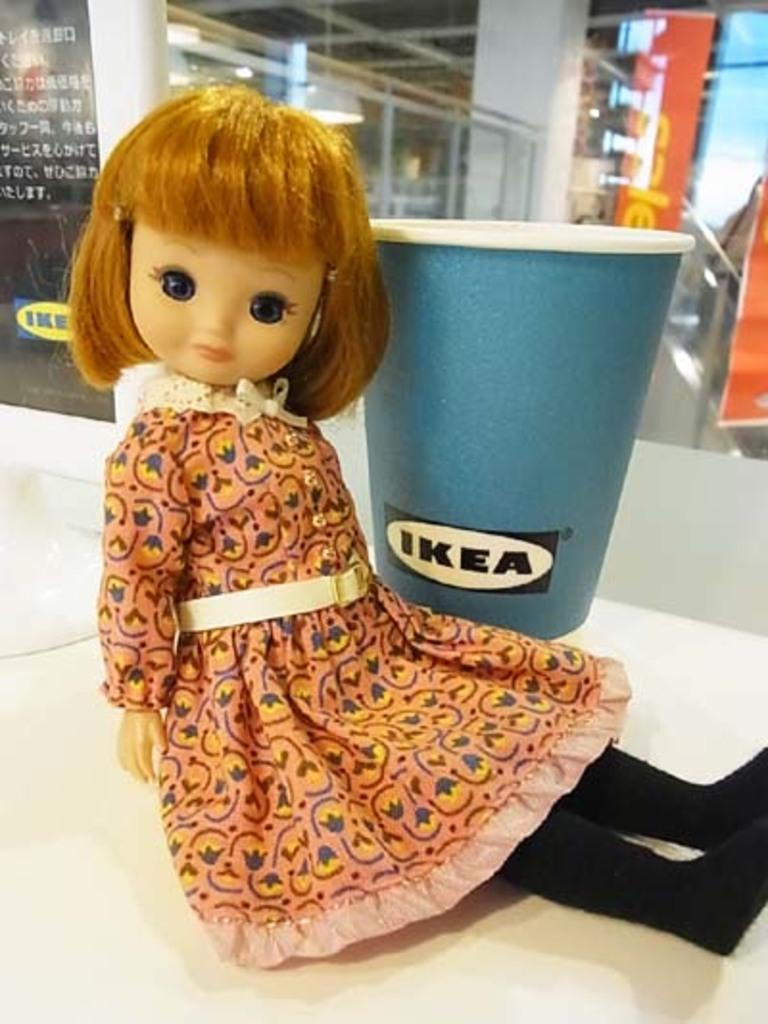What object can be seen in the image that is typically used for playing or displaying? There is a doll in the image that is typically used for playing or displaying. What object can be seen in the image that is typically used for holding liquids? There is a glass in the image that is typically used for holding liquids. What can be seen in the background of the image that might indicate a special occasion or event? There is a banner in the background of the image that might indicate a special occasion or event. What can be seen in the background of the image that allows light to enter the room? There is a glass window in the background of the image that allows light to enter the room. What type of ring can be seen on the doll's finger in the image? There is no ring visible on the doll's finger in the image. What degree of education does the person holding the glass have in the image? There is no person holding the glass in the image, so it is not possible to determine their level of education. 